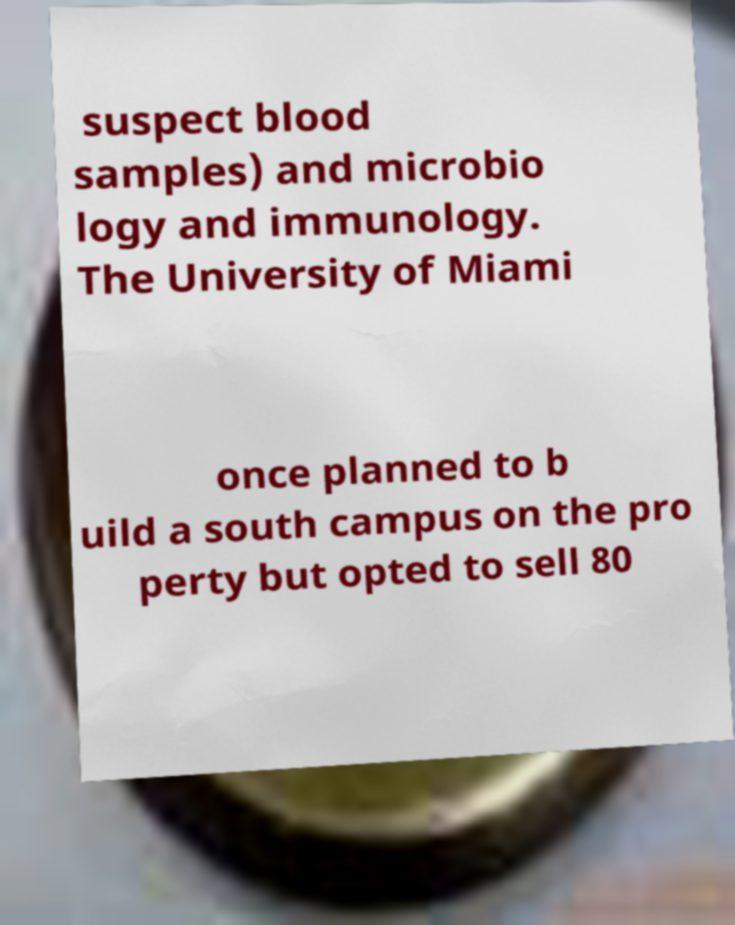Could you extract and type out the text from this image? suspect blood samples) and microbio logy and immunology. The University of Miami once planned to b uild a south campus on the pro perty but opted to sell 80 